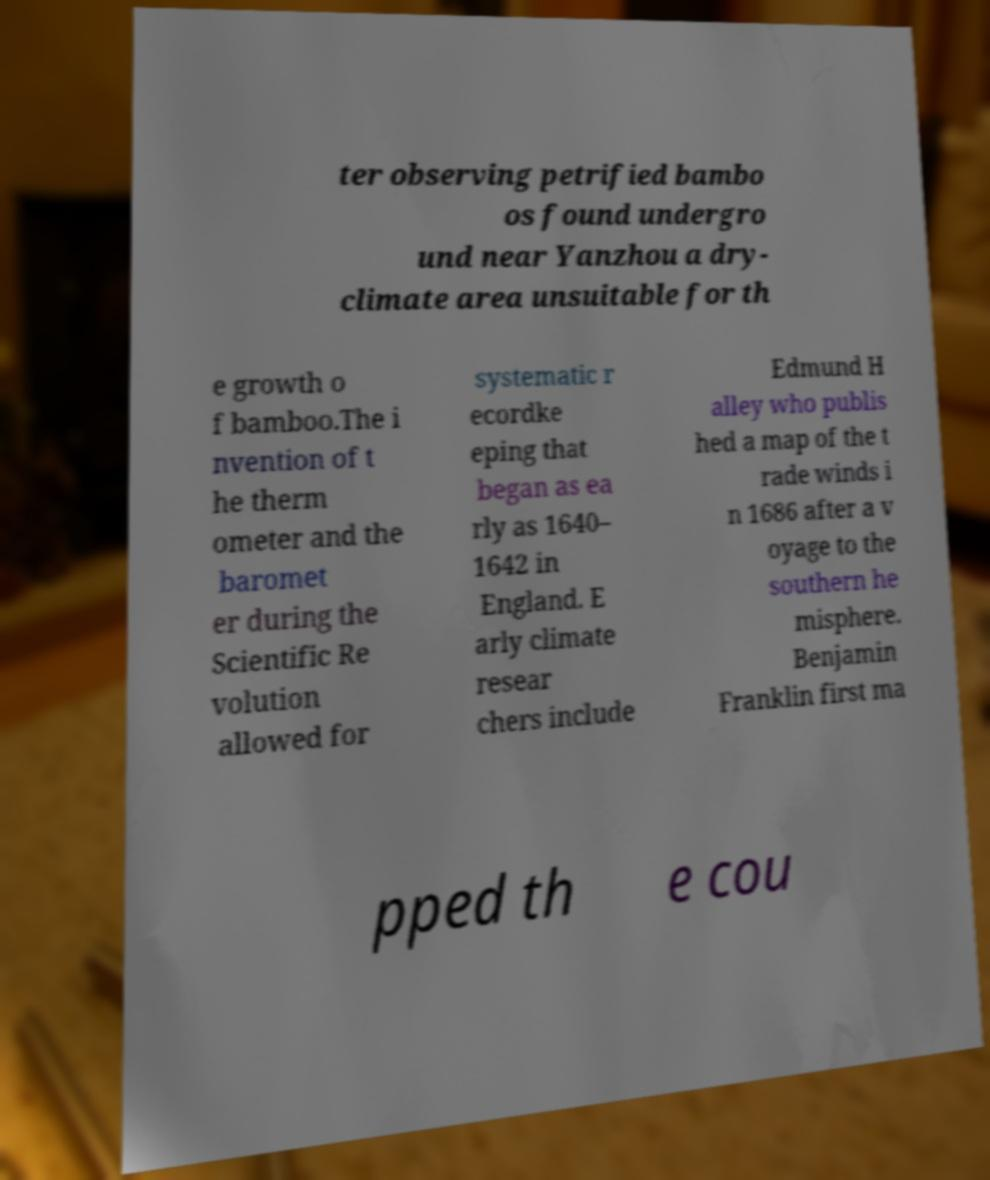For documentation purposes, I need the text within this image transcribed. Could you provide that? ter observing petrified bambo os found undergro und near Yanzhou a dry- climate area unsuitable for th e growth o f bamboo.The i nvention of t he therm ometer and the baromet er during the Scientific Re volution allowed for systematic r ecordke eping that began as ea rly as 1640– 1642 in England. E arly climate resear chers include Edmund H alley who publis hed a map of the t rade winds i n 1686 after a v oyage to the southern he misphere. Benjamin Franklin first ma pped th e cou 